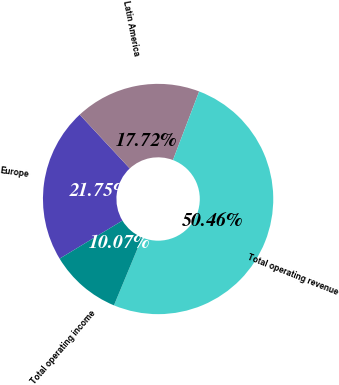Convert chart. <chart><loc_0><loc_0><loc_500><loc_500><pie_chart><fcel>Europe<fcel>Latin America<fcel>Total operating revenue<fcel>Total operating income<nl><fcel>21.75%<fcel>17.72%<fcel>50.46%<fcel>10.07%<nl></chart> 